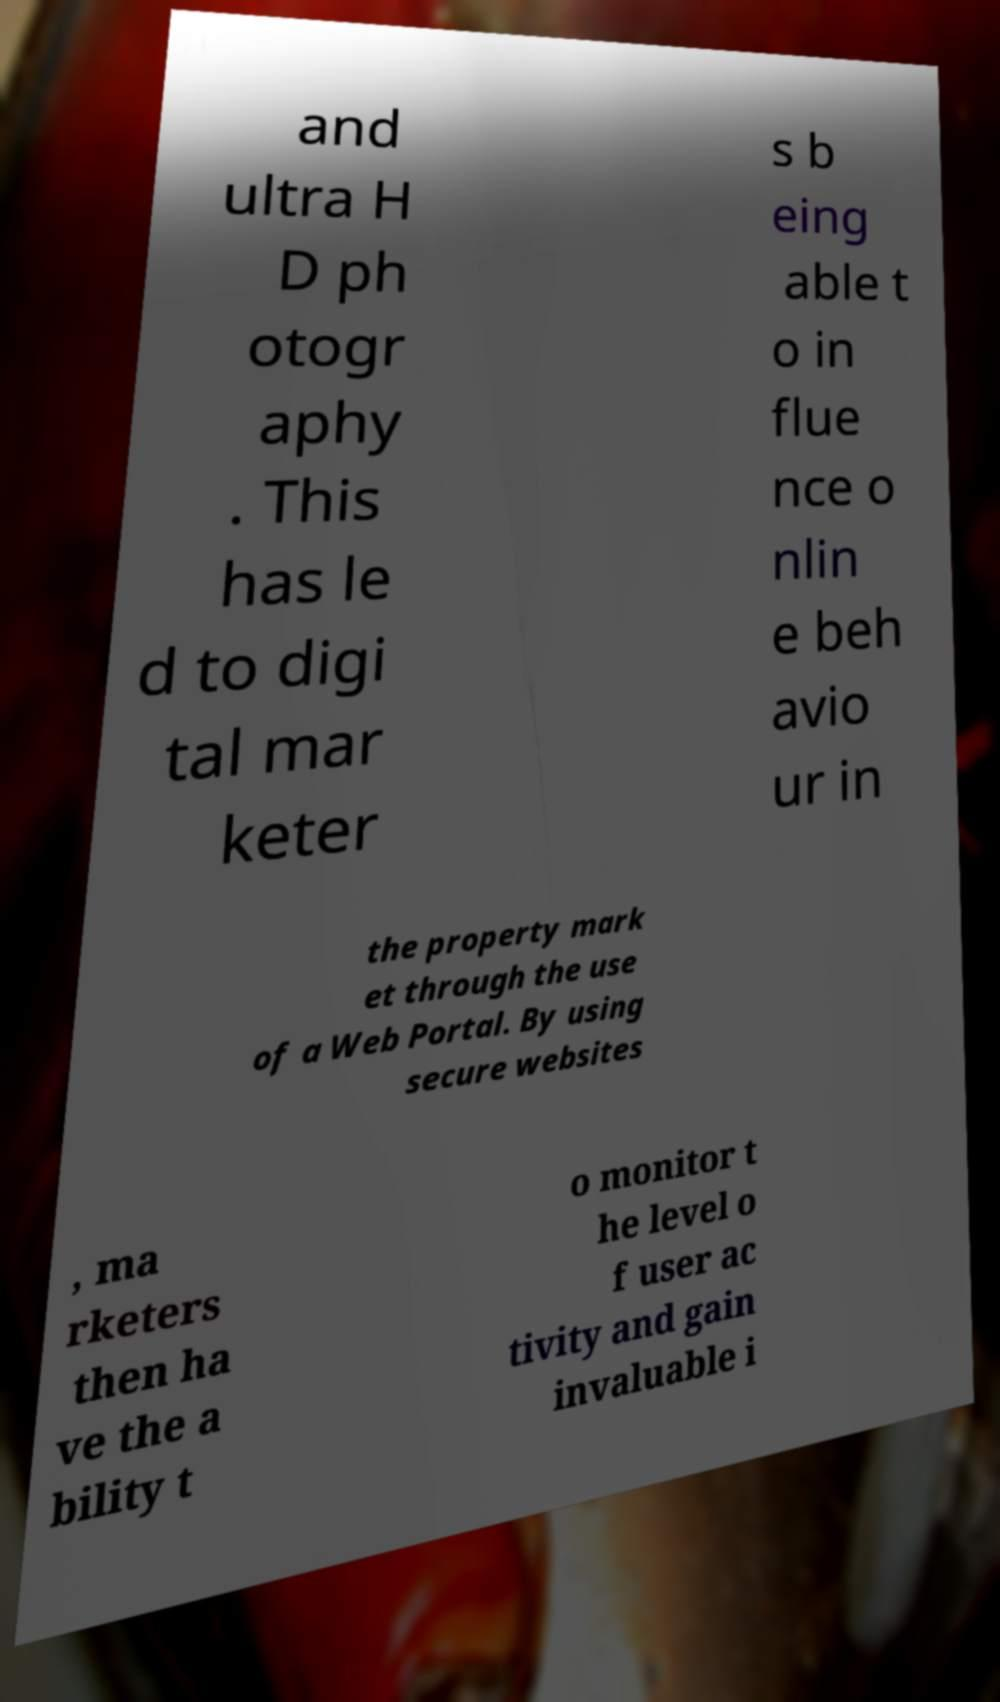Please read and relay the text visible in this image. What does it say? and ultra H D ph otogr aphy . This has le d to digi tal mar keter s b eing able t o in flue nce o nlin e beh avio ur in the property mark et through the use of a Web Portal. By using secure websites , ma rketers then ha ve the a bility t o monitor t he level o f user ac tivity and gain invaluable i 